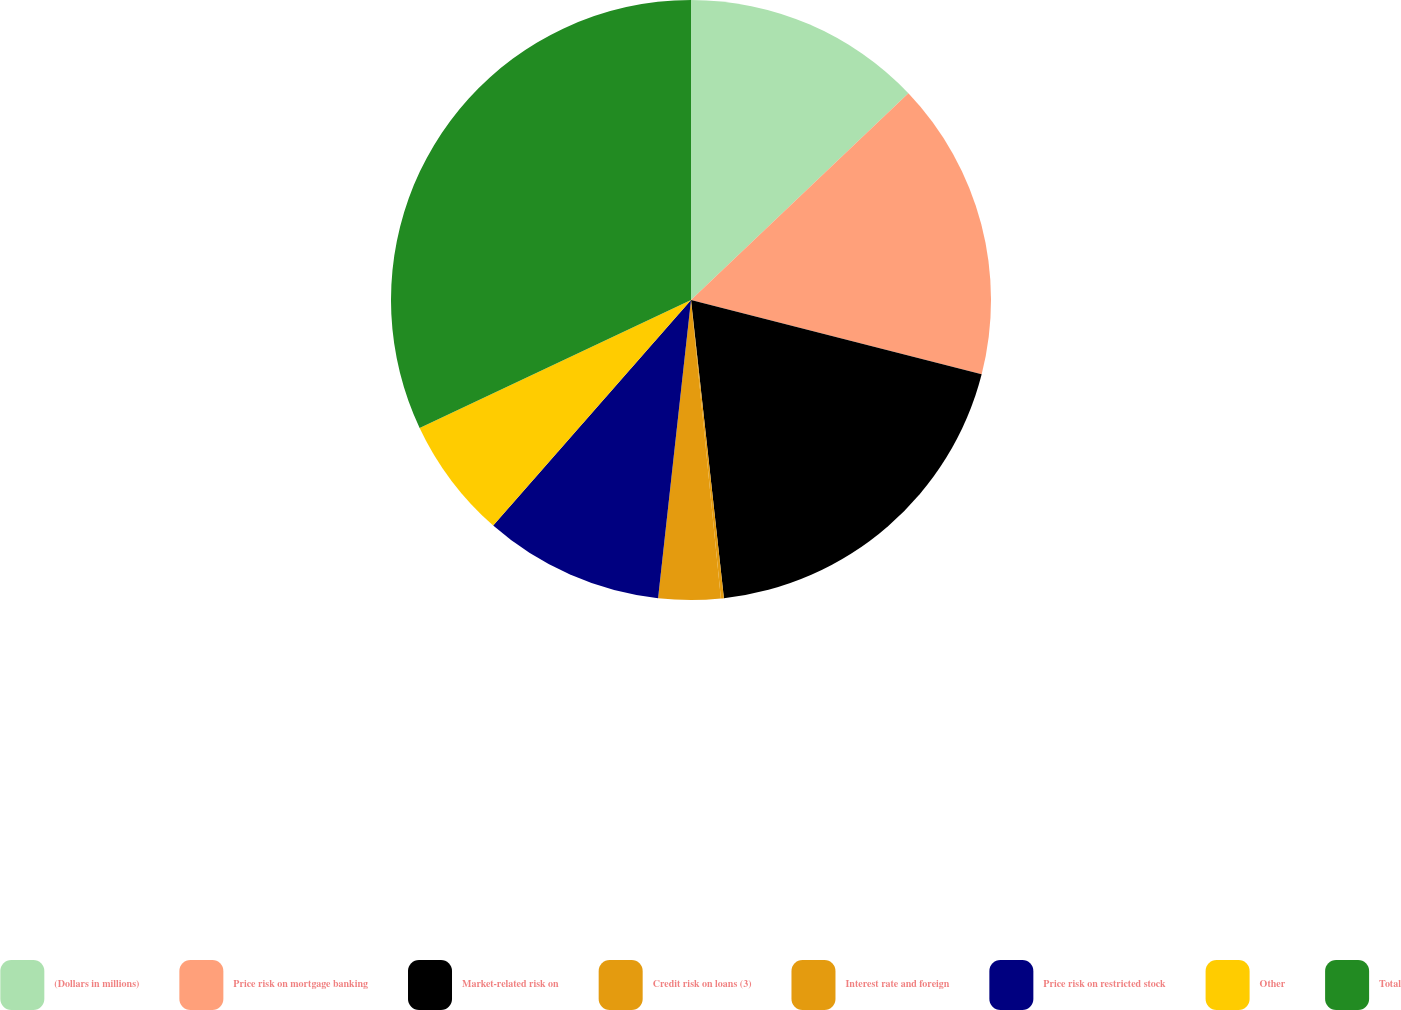<chart> <loc_0><loc_0><loc_500><loc_500><pie_chart><fcel>(Dollars in millions)<fcel>Price risk on mortgage banking<fcel>Market-related risk on<fcel>Credit risk on loans (3)<fcel>Interest rate and foreign<fcel>Price risk on restricted stock<fcel>Other<fcel>Total<nl><fcel>12.9%<fcel>16.08%<fcel>19.27%<fcel>0.16%<fcel>3.34%<fcel>9.71%<fcel>6.53%<fcel>32.01%<nl></chart> 